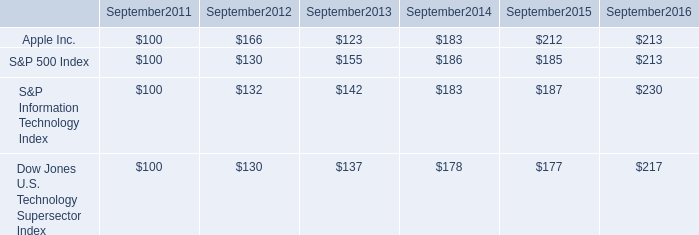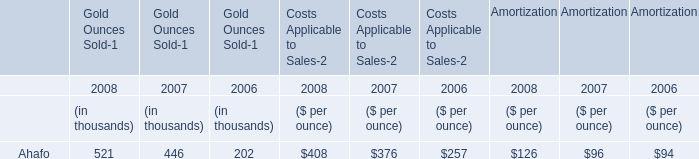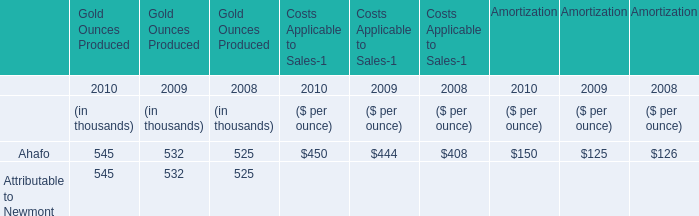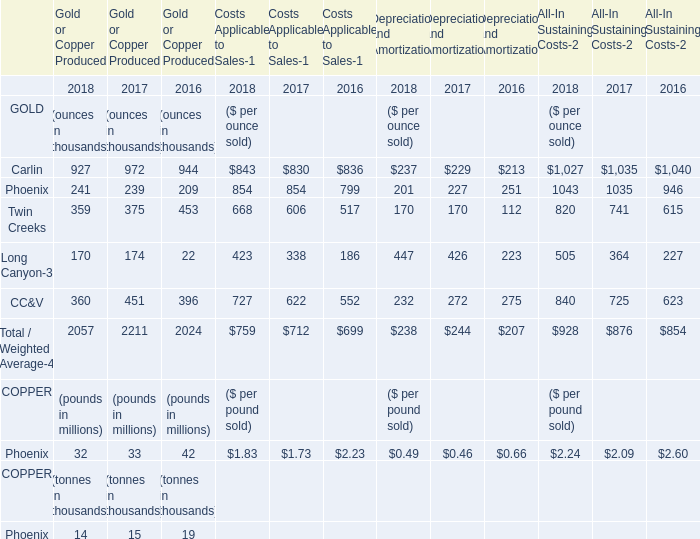What is the sum of Carlin, Phoenix and Twin Creeks in 2018 for Gold or Copper Produced? (in thousands) 
Computations: ((927 + 241) + 359)
Answer: 1527.0. 